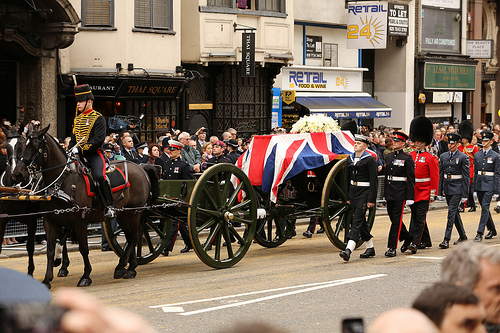Which kind of animal is brown? The brown animal is a horse. 